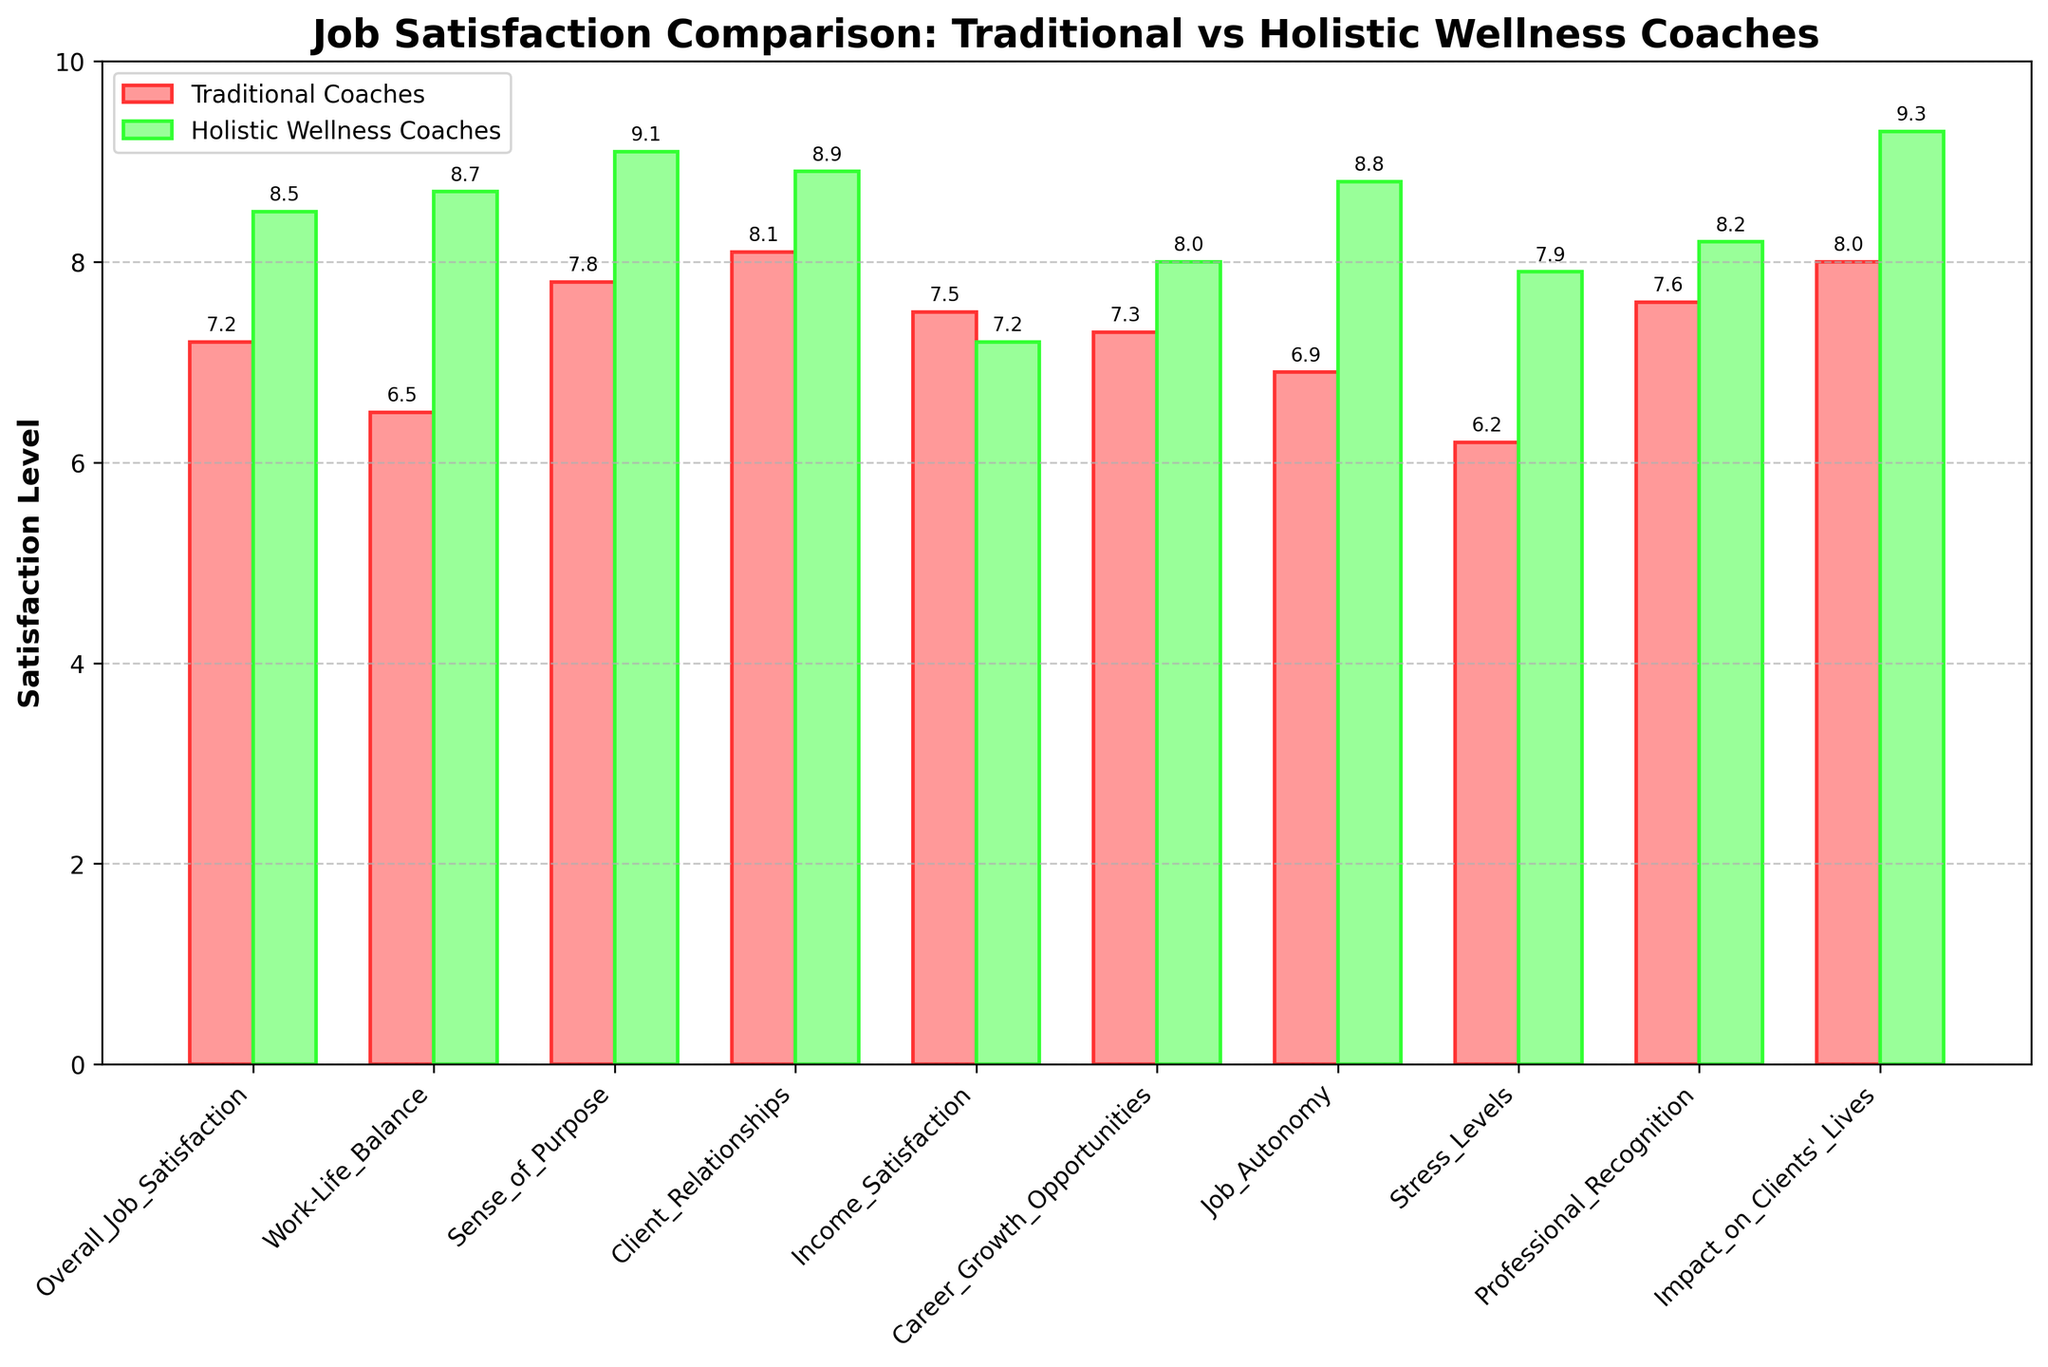How does the overall job satisfaction of holistic wellness coaches compare to that of traditional coaches? To compare the overall job satisfaction, observe the heights of the bars for "Overall_Job_Satisfaction" for both groups. The green bar (holistic wellness coaches) is taller than the red bar (traditional coaches).
Answer: Holistic wellness coaches have higher overall job satisfaction Which group has a higher satisfaction level in work-life balance? By looking at the "Work-Life_Balance" bars, the green bar (holistic wellness coaches) is considerably taller than the red bar (traditional coaches).
Answer: Holistic wellness coaches have a higher satisfaction level in work-life balance What is the difference in satisfaction levels for job autonomy between holistic wellness coaches and traditional coaches? The "Job_Autonomy" satisfaction levels are 8.8 for holistic wellness coaches and 6.9 for traditional coaches. Subtract the two values: 8.8 - 6.9.
Answer: 1.9 Which group feels a greater sense of purpose in their job? Looking at the "Sense_of_Purpose" segment, the green bar (holistic wellness coaches) is higher than the red bar (traditional coaches).
Answer: Holistic wellness coaches feel a greater sense of purpose By how much do traditional coaches score higher in income satisfaction compared to holistic wellness coaches? For "Income_Satisfaction," the red bar (traditional coaches) has a value of 7.5, while the green bar (holistic wellness coaches) is at 7.2. Subtract: 7.5 - 7.2.
Answer: 0.3 What is the combined satisfaction score for client relationships and career growth opportunities for traditional coaches? The satisfaction scores are 8.1 (client relationships) and 7.3 (career growth opportunities). Add them together: 8.1 + 7.3.
Answer: 15.4 Which job aspect has the smallest difference in satisfaction levels between the two groups, and what is that difference? To find the smallest difference, calculate the differences for each aspect and identify the smallest. For instance, "Income_Satisfaction" difference is 0.3, check the rest to confirm it's the smallest.
Answer: Income satisfaction, 0.3 In terms of professional recognition, by what factor is the satisfaction level of holistic wellness coaches higher than that of traditional coaches? The satisfaction levels are 8.2 (holistic wellness coaches) and 7.6 (traditional coaches). Divide: 8.2 / 7.6.
Answer: 1.08 Is the impact on clients' lives reported higher by holistic wellness coaches or traditional coaches, and by how much? The "Impact_on_Clients'_Lives" satisfaction levels are 9.3 for holistic wellness coaches and 8.0 for traditional coaches. Subtract: 9.3 - 8.0.
Answer: Holistic wellness coaches by 1.3 Which job aspect shows the greatest disparity in satisfaction levels between the two groups, and what is the exact numerical difference? Calculate the differences for each aspect and identify the greatest. For instance, "Job_Autonomy" difference is 1.9, check the rest to find the largest disparity.
Answer: Job autonomy, 1.9 